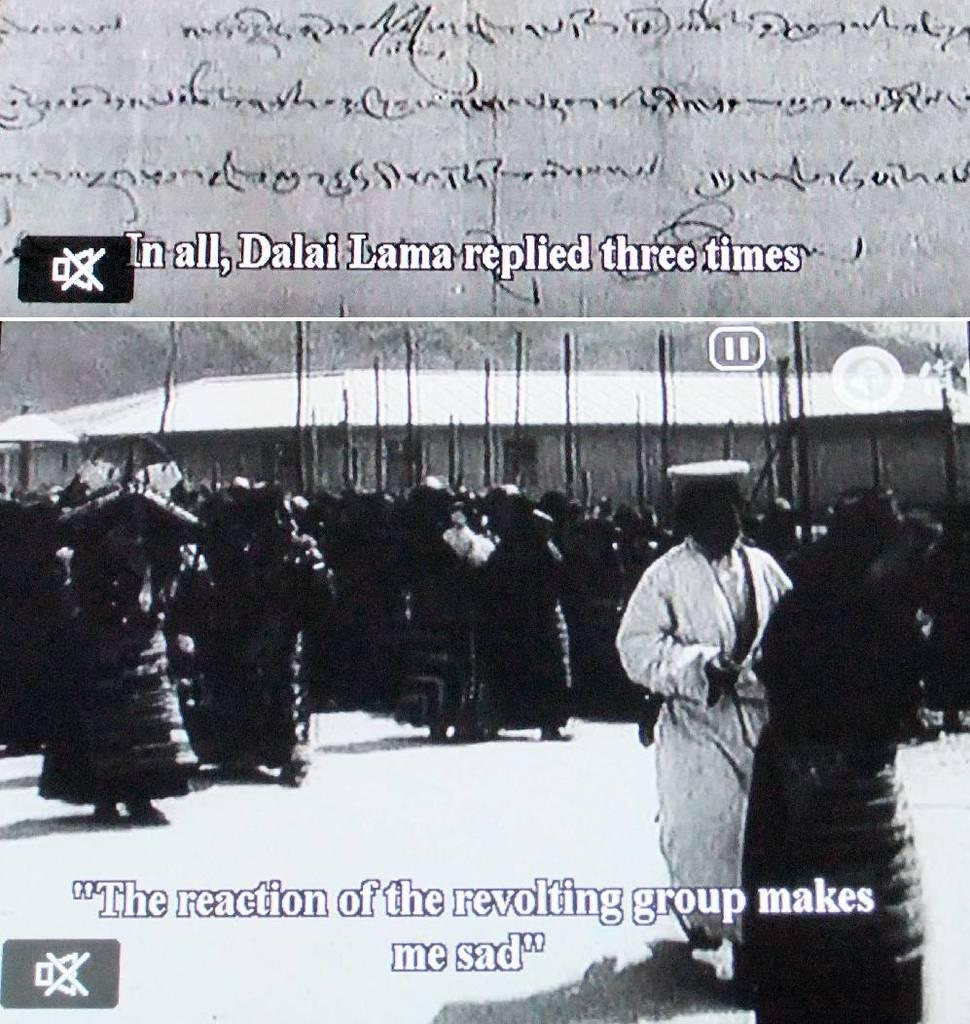What is the main subject of the image? The main subject of the image is a collage of a picture. What can be seen in the picture? The picture contains a group of persons. Can you describe any specific details about the persons in the picture? One person in the group is wearing a white dress and holding a stick in their hand. What type of spring can be seen in the picture? There is no spring present in the picture; it features a collage of a picture with a group of persons. How many minutes does the notebook in the picture have left? There is no notebook present in the picture. 